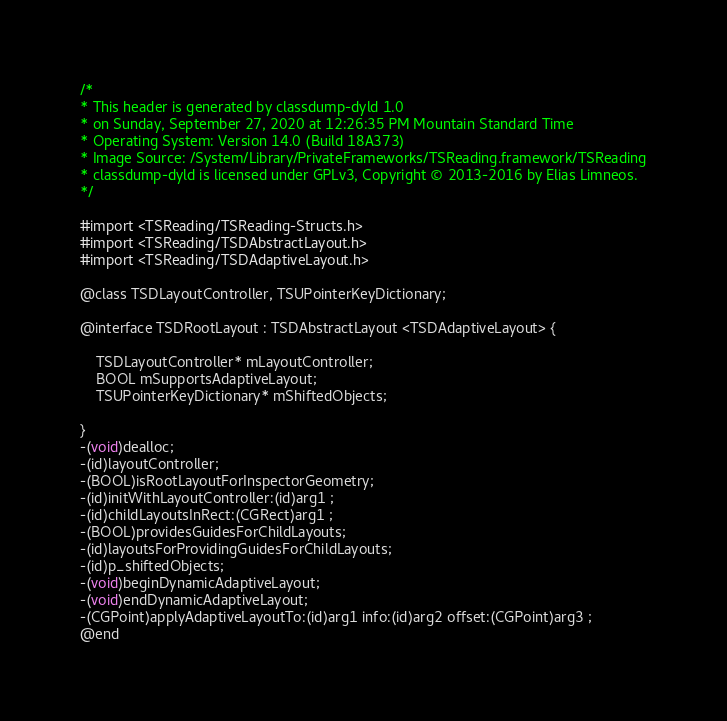Convert code to text. <code><loc_0><loc_0><loc_500><loc_500><_C_>/*
* This header is generated by classdump-dyld 1.0
* on Sunday, September 27, 2020 at 12:26:35 PM Mountain Standard Time
* Operating System: Version 14.0 (Build 18A373)
* Image Source: /System/Library/PrivateFrameworks/TSReading.framework/TSReading
* classdump-dyld is licensed under GPLv3, Copyright © 2013-2016 by Elias Limneos.
*/

#import <TSReading/TSReading-Structs.h>
#import <TSReading/TSDAbstractLayout.h>
#import <TSReading/TSDAdaptiveLayout.h>

@class TSDLayoutController, TSUPointerKeyDictionary;

@interface TSDRootLayout : TSDAbstractLayout <TSDAdaptiveLayout> {

	TSDLayoutController* mLayoutController;
	BOOL mSupportsAdaptiveLayout;
	TSUPointerKeyDictionary* mShiftedObjects;

}
-(void)dealloc;
-(id)layoutController;
-(BOOL)isRootLayoutForInspectorGeometry;
-(id)initWithLayoutController:(id)arg1 ;
-(id)childLayoutsInRect:(CGRect)arg1 ;
-(BOOL)providesGuidesForChildLayouts;
-(id)layoutsForProvidingGuidesForChildLayouts;
-(id)p_shiftedObjects;
-(void)beginDynamicAdaptiveLayout;
-(void)endDynamicAdaptiveLayout;
-(CGPoint)applyAdaptiveLayoutTo:(id)arg1 info:(id)arg2 offset:(CGPoint)arg3 ;
@end

</code> 